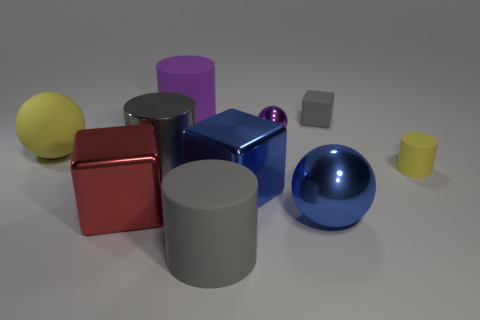Subtract all rubber cylinders. How many cylinders are left? 1 Subtract all blue blocks. How many gray cylinders are left? 2 Subtract 1 spheres. How many spheres are left? 2 Subtract all purple cylinders. How many cylinders are left? 3 Subtract all cubes. How many objects are left? 7 Subtract all red cylinders. Subtract all brown cubes. How many cylinders are left? 4 Subtract all rubber blocks. Subtract all cubes. How many objects are left? 6 Add 2 small purple objects. How many small purple objects are left? 3 Add 6 blue things. How many blue things exist? 8 Subtract 2 gray cylinders. How many objects are left? 8 